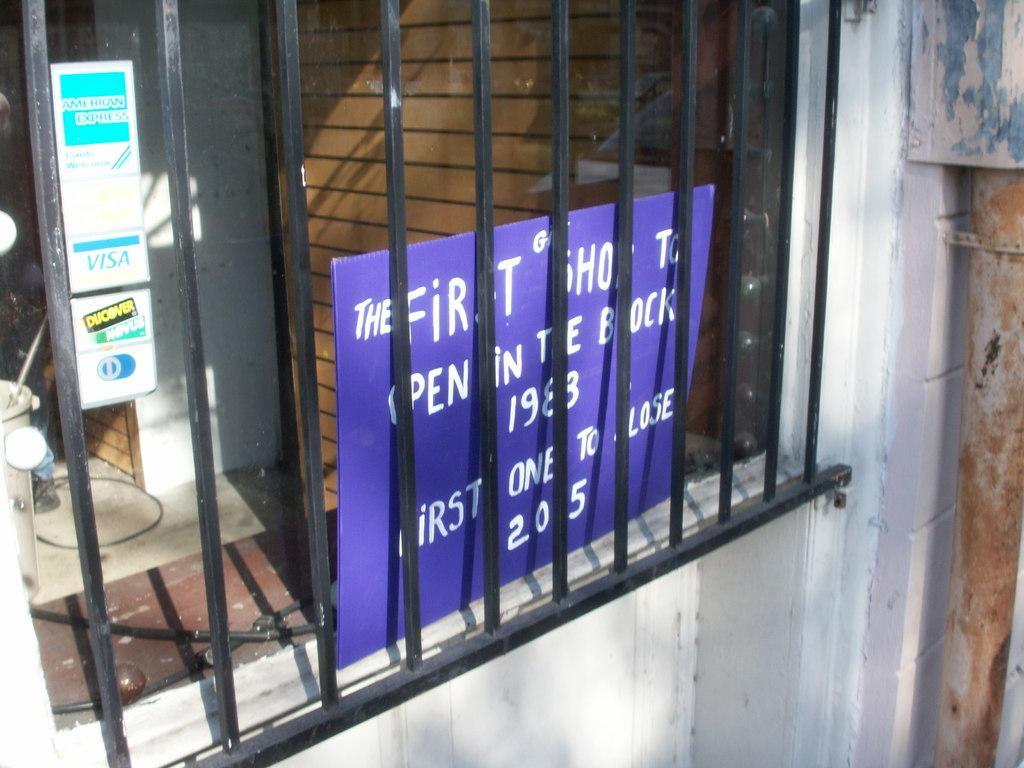What type of structure can be seen in the image? There is a wall in the image. What feature is present in the wall? There is a window in the image. What can be seen through the window? Posters are visible through the window. How many cacti are present in the image? There are no cacti visible in the image. What is the size of the orange in the image? There is no orange present in the image. 